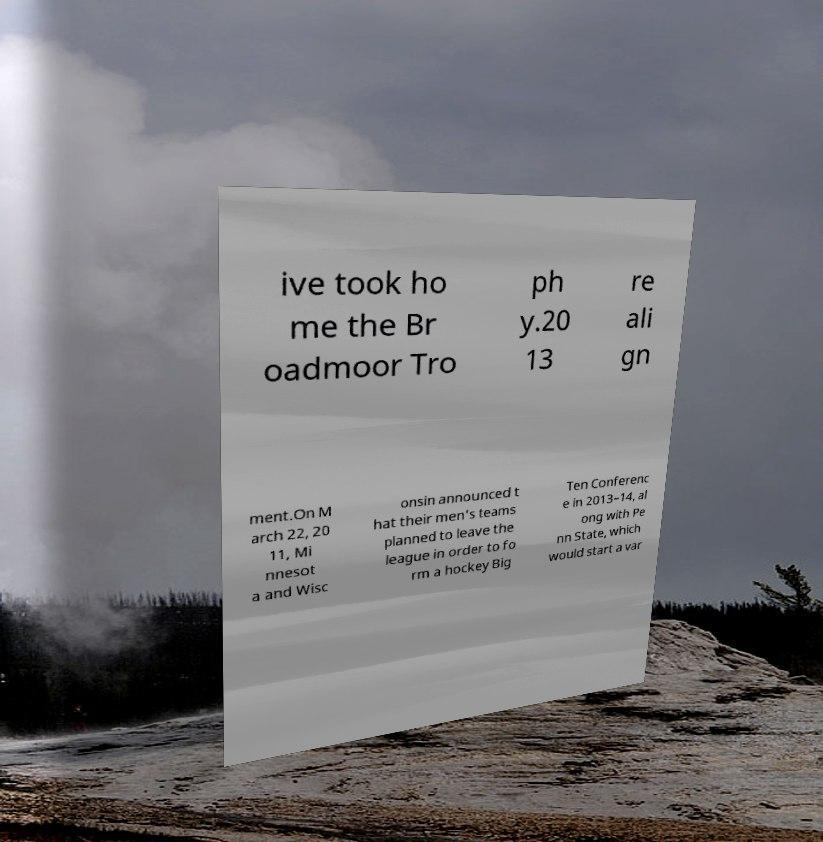Please identify and transcribe the text found in this image. ive took ho me the Br oadmoor Tro ph y.20 13 re ali gn ment.On M arch 22, 20 11, Mi nnesot a and Wisc onsin announced t hat their men's teams planned to leave the league in order to fo rm a hockey Big Ten Conferenc e in 2013–14, al ong with Pe nn State, which would start a var 